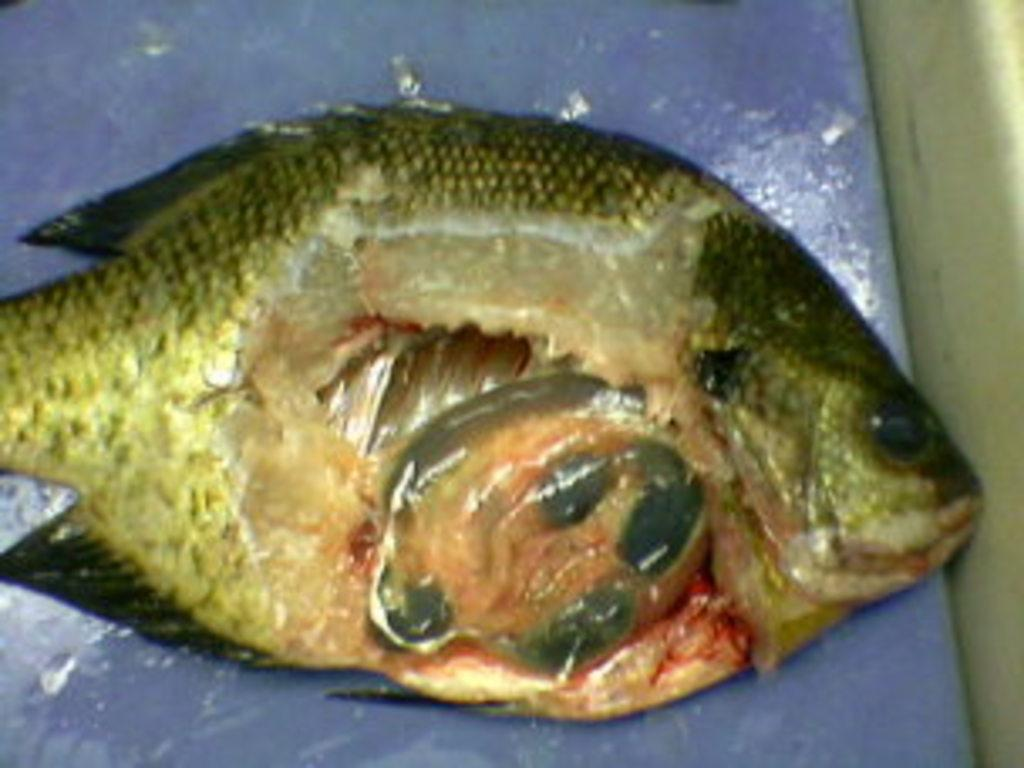What type of animals can be seen on the surface in the image? There are fish on the surface in the image. What type of list can be seen hanging on the wall in the image? There is no list present in the image; it only features fish on the surface. 